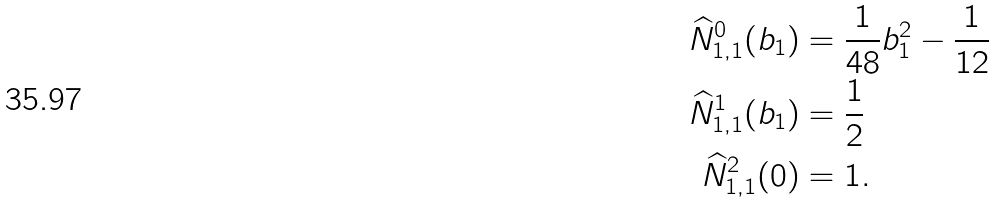<formula> <loc_0><loc_0><loc_500><loc_500>\widehat { N } _ { 1 , 1 } ^ { 0 } ( b _ { 1 } ) & = \frac { 1 } { 4 8 } b _ { 1 } ^ { 2 } - \frac { 1 } { 1 2 } \\ \widehat { N } _ { 1 , 1 } ^ { 1 } ( b _ { 1 } ) & = \frac { 1 } { 2 } \\ \widehat { N } _ { 1 , 1 } ^ { 2 } ( 0 ) & = 1 .</formula> 